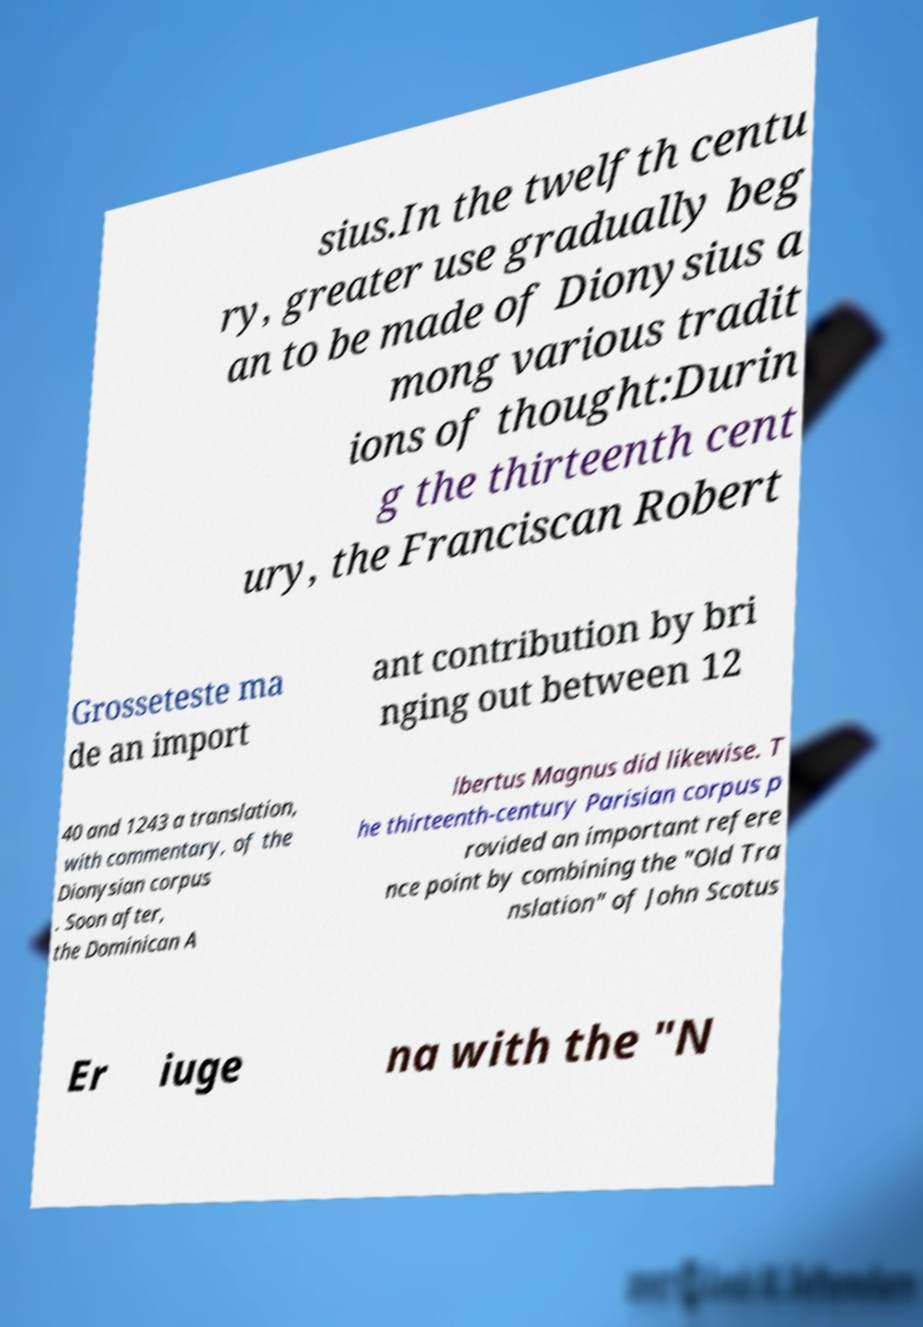Please read and relay the text visible in this image. What does it say? sius.In the twelfth centu ry, greater use gradually beg an to be made of Dionysius a mong various tradit ions of thought:Durin g the thirteenth cent ury, the Franciscan Robert Grosseteste ma de an import ant contribution by bri nging out between 12 40 and 1243 a translation, with commentary, of the Dionysian corpus . Soon after, the Dominican A lbertus Magnus did likewise. T he thirteenth-century Parisian corpus p rovided an important refere nce point by combining the "Old Tra nslation" of John Scotus Er iuge na with the "N 